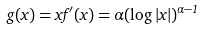Convert formula to latex. <formula><loc_0><loc_0><loc_500><loc_500>g ( x ) = x f ^ { \prime } ( x ) = \alpha ( \log | x | ) ^ { \alpha - 1 }</formula> 